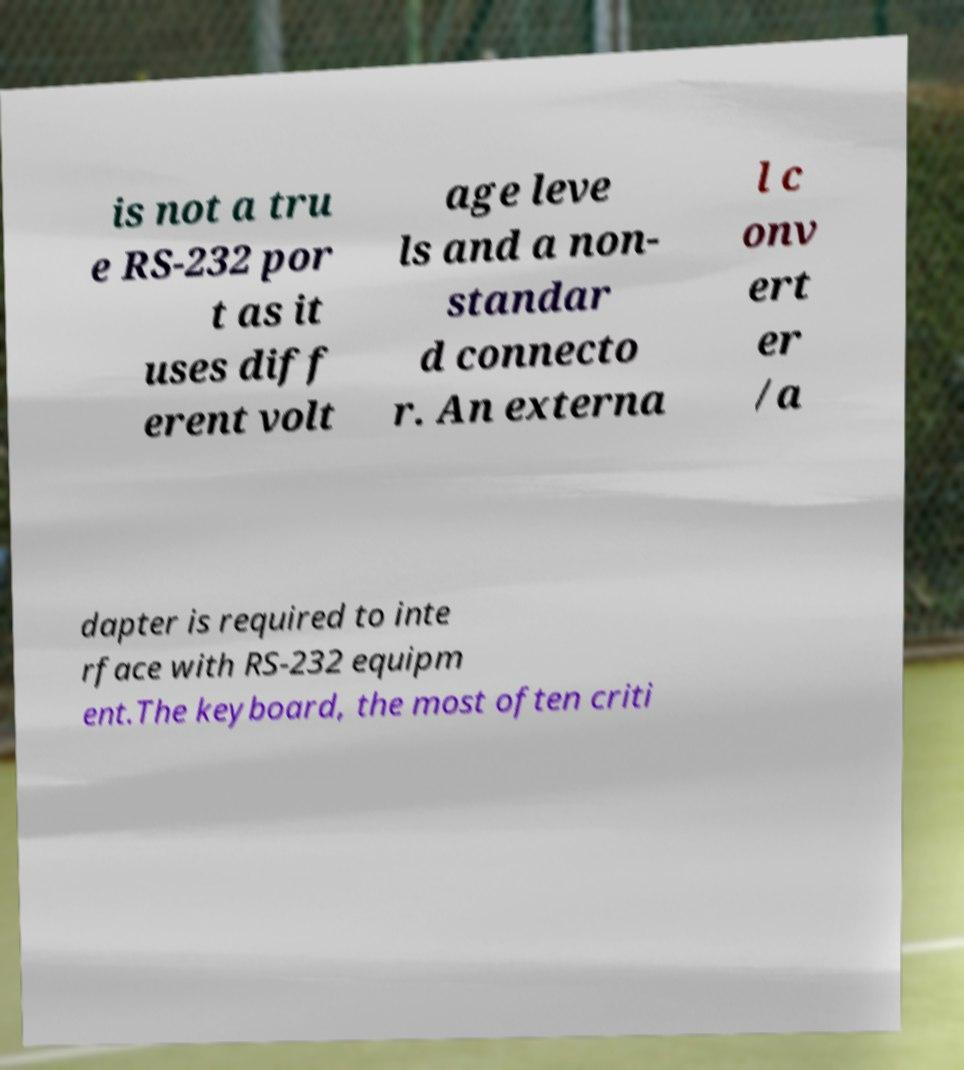Can you read and provide the text displayed in the image?This photo seems to have some interesting text. Can you extract and type it out for me? is not a tru e RS-232 por t as it uses diff erent volt age leve ls and a non- standar d connecto r. An externa l c onv ert er /a dapter is required to inte rface with RS-232 equipm ent.The keyboard, the most often criti 